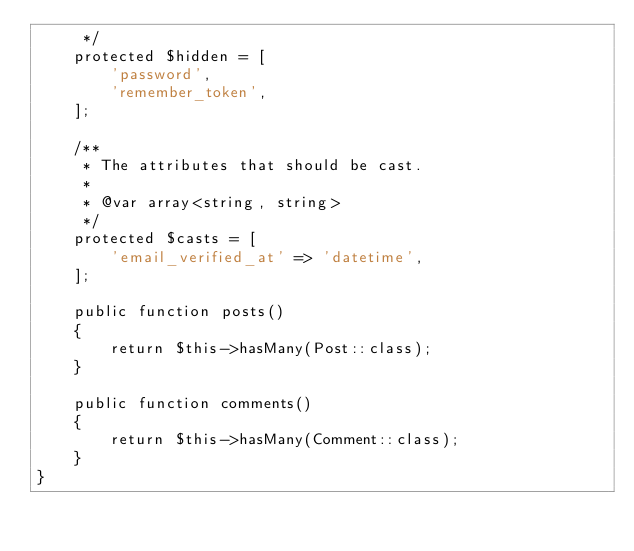<code> <loc_0><loc_0><loc_500><loc_500><_PHP_>     */
    protected $hidden = [
        'password',
        'remember_token',
    ];

    /**
     * The attributes that should be cast.
     *
     * @var array<string, string>
     */
    protected $casts = [
        'email_verified_at' => 'datetime',
    ];

    public function posts()
    {
        return $this->hasMany(Post::class);
    }

    public function comments()
    {
        return $this->hasMany(Comment::class);
    }
}
</code> 